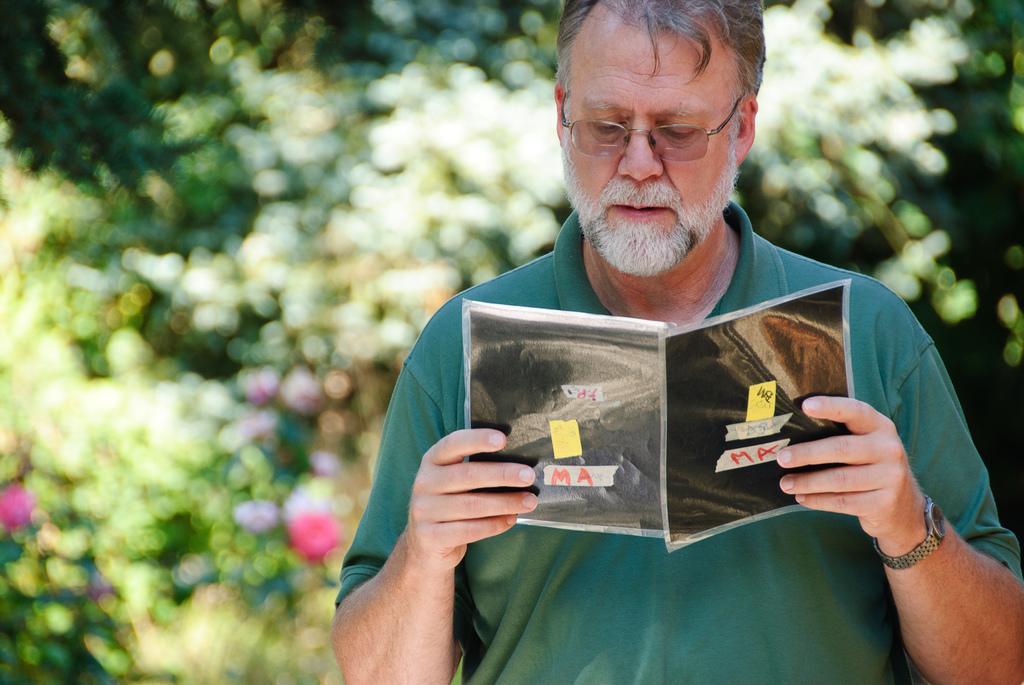Can you describe this image briefly? In this image I can see a person holding a book and background is too blur 